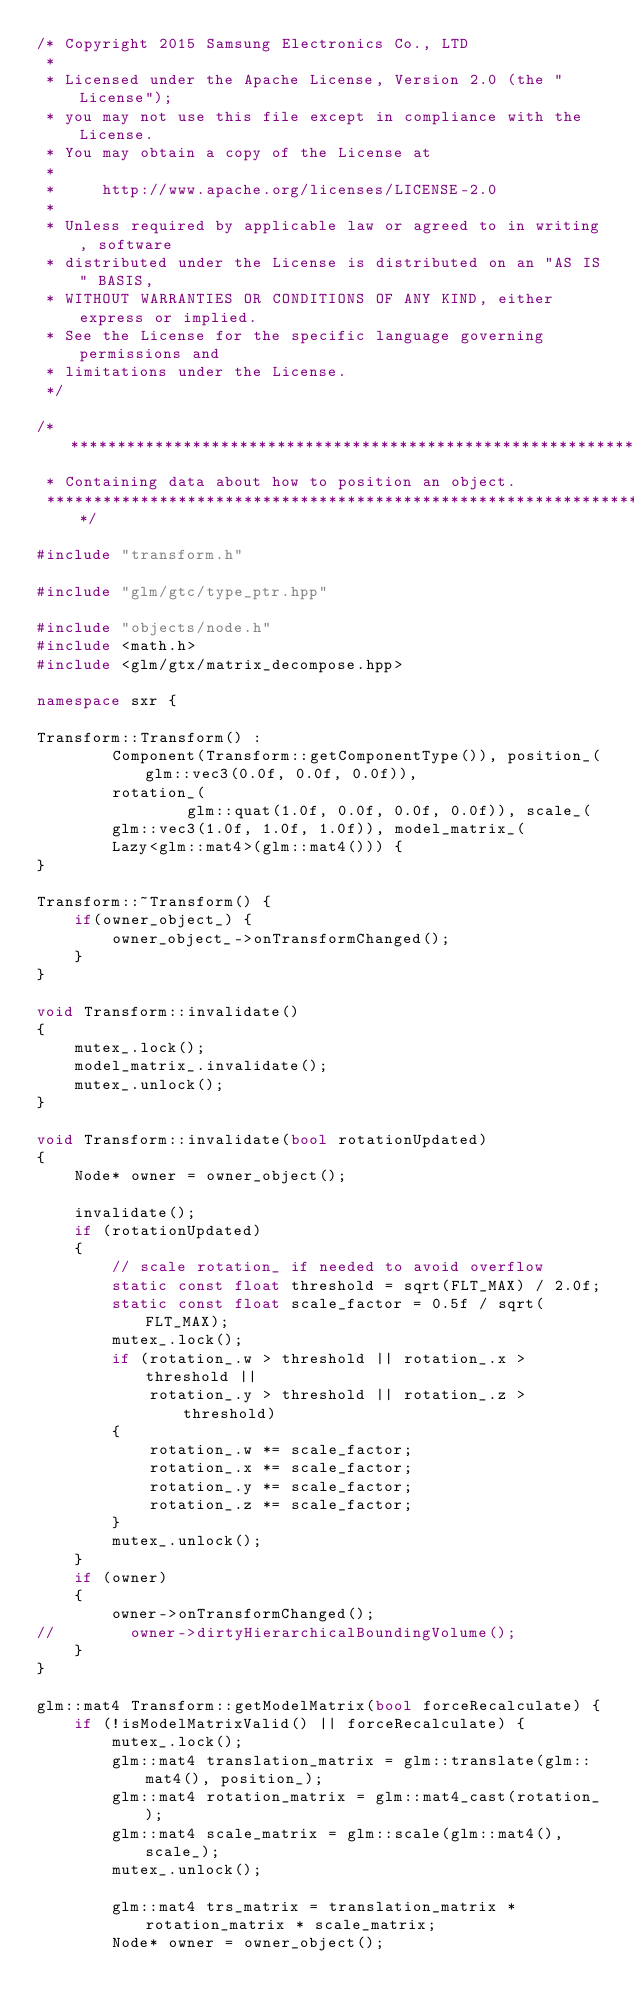Convert code to text. <code><loc_0><loc_0><loc_500><loc_500><_C++_>/* Copyright 2015 Samsung Electronics Co., LTD
 *
 * Licensed under the Apache License, Version 2.0 (the "License");
 * you may not use this file except in compliance with the License.
 * You may obtain a copy of the License at
 *
 *     http://www.apache.org/licenses/LICENSE-2.0
 *
 * Unless required by applicable law or agreed to in writing, software
 * distributed under the License is distributed on an "AS IS" BASIS,
 * WITHOUT WARRANTIES OR CONDITIONS OF ANY KIND, either express or implied.
 * See the License for the specific language governing permissions and
 * limitations under the License.
 */

/***************************************************************************
 * Containing data about how to position an object.
 ***************************************************************************/

#include "transform.h"

#include "glm/gtc/type_ptr.hpp"

#include "objects/node.h"
#include <math.h>
#include <glm/gtx/matrix_decompose.hpp>

namespace sxr {

Transform::Transform() :
        Component(Transform::getComponentType()), position_(glm::vec3(0.0f, 0.0f, 0.0f)),
        rotation_(
                glm::quat(1.0f, 0.0f, 0.0f, 0.0f)), scale_(
        glm::vec3(1.0f, 1.0f, 1.0f)), model_matrix_(
        Lazy<glm::mat4>(glm::mat4())) {
}

Transform::~Transform() {
    if(owner_object_) {
        owner_object_->onTransformChanged();
    }
}

void Transform::invalidate()
{
    mutex_.lock();
    model_matrix_.invalidate();
    mutex_.unlock();
}

void Transform::invalidate(bool rotationUpdated)
{
    Node* owner = owner_object();

    invalidate();
    if (rotationUpdated)
    {
        // scale rotation_ if needed to avoid overflow
        static const float threshold = sqrt(FLT_MAX) / 2.0f;
        static const float scale_factor = 0.5f / sqrt(FLT_MAX);
        mutex_.lock();
        if (rotation_.w > threshold || rotation_.x > threshold ||
            rotation_.y > threshold || rotation_.z > threshold)
        {
            rotation_.w *= scale_factor;
            rotation_.x *= scale_factor;
            rotation_.y *= scale_factor;
            rotation_.z *= scale_factor;
        }
        mutex_.unlock();
    }
    if (owner)
    {
        owner->onTransformChanged();
//        owner->dirtyHierarchicalBoundingVolume();
    }
}

glm::mat4 Transform::getModelMatrix(bool forceRecalculate) {
    if (!isModelMatrixValid() || forceRecalculate) {
        mutex_.lock();
        glm::mat4 translation_matrix = glm::translate(glm::mat4(), position_);
        glm::mat4 rotation_matrix = glm::mat4_cast(rotation_);
        glm::mat4 scale_matrix = glm::scale(glm::mat4(), scale_);
        mutex_.unlock();

        glm::mat4 trs_matrix = translation_matrix * rotation_matrix * scale_matrix;
        Node* owner = owner_object();</code> 